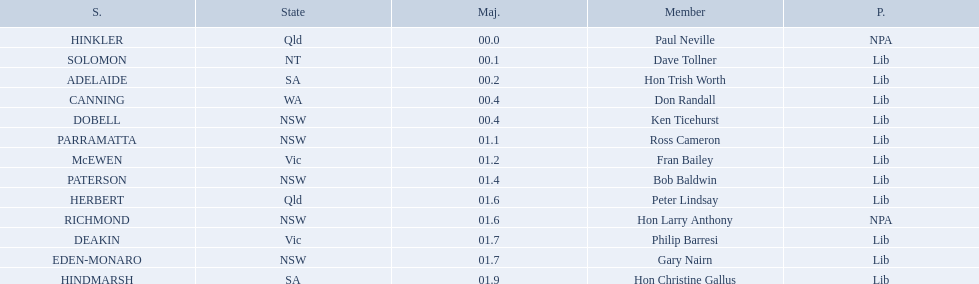Who are all the lib party members? Dave Tollner, Hon Trish Worth, Don Randall, Ken Ticehurst, Ross Cameron, Fran Bailey, Bob Baldwin, Peter Lindsay, Philip Barresi, Gary Nairn, Hon Christine Gallus. What lib party members are in sa? Hon Trish Worth, Hon Christine Gallus. What is the highest difference in majority between members in sa? 01.9. What state does hinkler belong too? Qld. Could you parse the entire table as a dict? {'header': ['S.', 'State', 'Maj.', 'Member', 'P.'], 'rows': [['HINKLER', 'Qld', '00.0', 'Paul Neville', 'NPA'], ['SOLOMON', 'NT', '00.1', 'Dave Tollner', 'Lib'], ['ADELAIDE', 'SA', '00.2', 'Hon Trish Worth', 'Lib'], ['CANNING', 'WA', '00.4', 'Don Randall', 'Lib'], ['DOBELL', 'NSW', '00.4', 'Ken Ticehurst', 'Lib'], ['PARRAMATTA', 'NSW', '01.1', 'Ross Cameron', 'Lib'], ['McEWEN', 'Vic', '01.2', 'Fran Bailey', 'Lib'], ['PATERSON', 'NSW', '01.4', 'Bob Baldwin', 'Lib'], ['HERBERT', 'Qld', '01.6', 'Peter Lindsay', 'Lib'], ['RICHMOND', 'NSW', '01.6', 'Hon Larry Anthony', 'NPA'], ['DEAKIN', 'Vic', '01.7', 'Philip Barresi', 'Lib'], ['EDEN-MONARO', 'NSW', '01.7', 'Gary Nairn', 'Lib'], ['HINDMARSH', 'SA', '01.9', 'Hon Christine Gallus', 'Lib']]} What is the majority of difference between sa and qld? 01.9. 